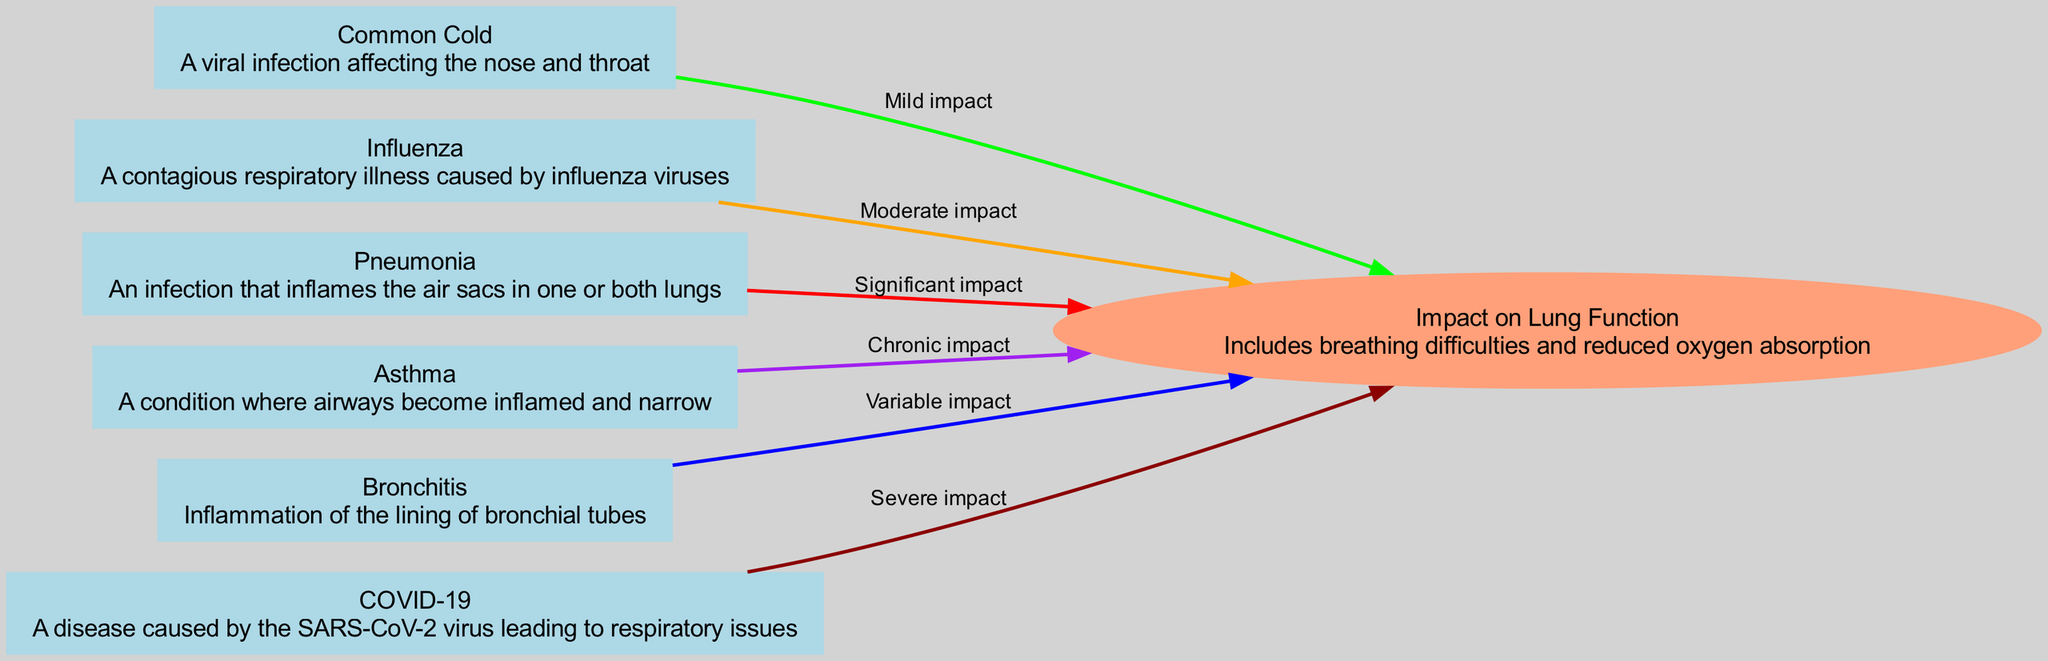What is the label of the node representing pneumonia? The node for pneumonia is labeled "Pneumonia". This is directly taken from the diagram data provided in the nodes section.
Answer: Pneumonia How many nodes are there in the diagram? The diagram contains a total of six nodes that represent various common respiratory illnesses and their effects. By counting the nodes from the provided data, we confirm they are: commonCold, influenza, pneumonia, asthma, bronchitis, and covid19.
Answer: 6 What type of impact does the common cold have on lung function? According to the diagram, the common cold has a "Mild impact" on lung function. This is specified in the edge relationship between the common cold and the lung function impact.
Answer: Mild impact Which respiratory illness leads to severe impact on lung function? The diagram indicates that COVID-19 leads to a "Severe impact" on lung function. This relationship is drawn from the edge that connects COVID-19 to the impact on lung function.
Answer: COVID-19 What relationship exists between asthma and lung function impact? The diagram shows that asthma has a "Chronic impact" on lung function. This is defined by the labeled edge from asthma to lung function impact in the visual data provided.
Answer: Chronic impact How does pneumonia affect lung function compared to bronchitis? Pneumonia has a "Significant impact" on lung function, while bronchitis has a "Variable impact." By comparing the edges from both nodes to the lung function impact node, we see the difference in the severity of impact.
Answer: Pneumonia has Significant impact, Bronchitis has Variable impact Which illness has a moderate impact on lung function? The inflammation caused by influenza is described as having a "Moderate impact" on lung function according to the edge connecting influenza and lung function impact.
Answer: Influenza What is the relationship label between bronchitis and lung function impact? The relationship label connecting bronchitis to lung function impact is "Variable impact". This detail is highlighted in the edge noted in the diagram.
Answer: Variable impact 